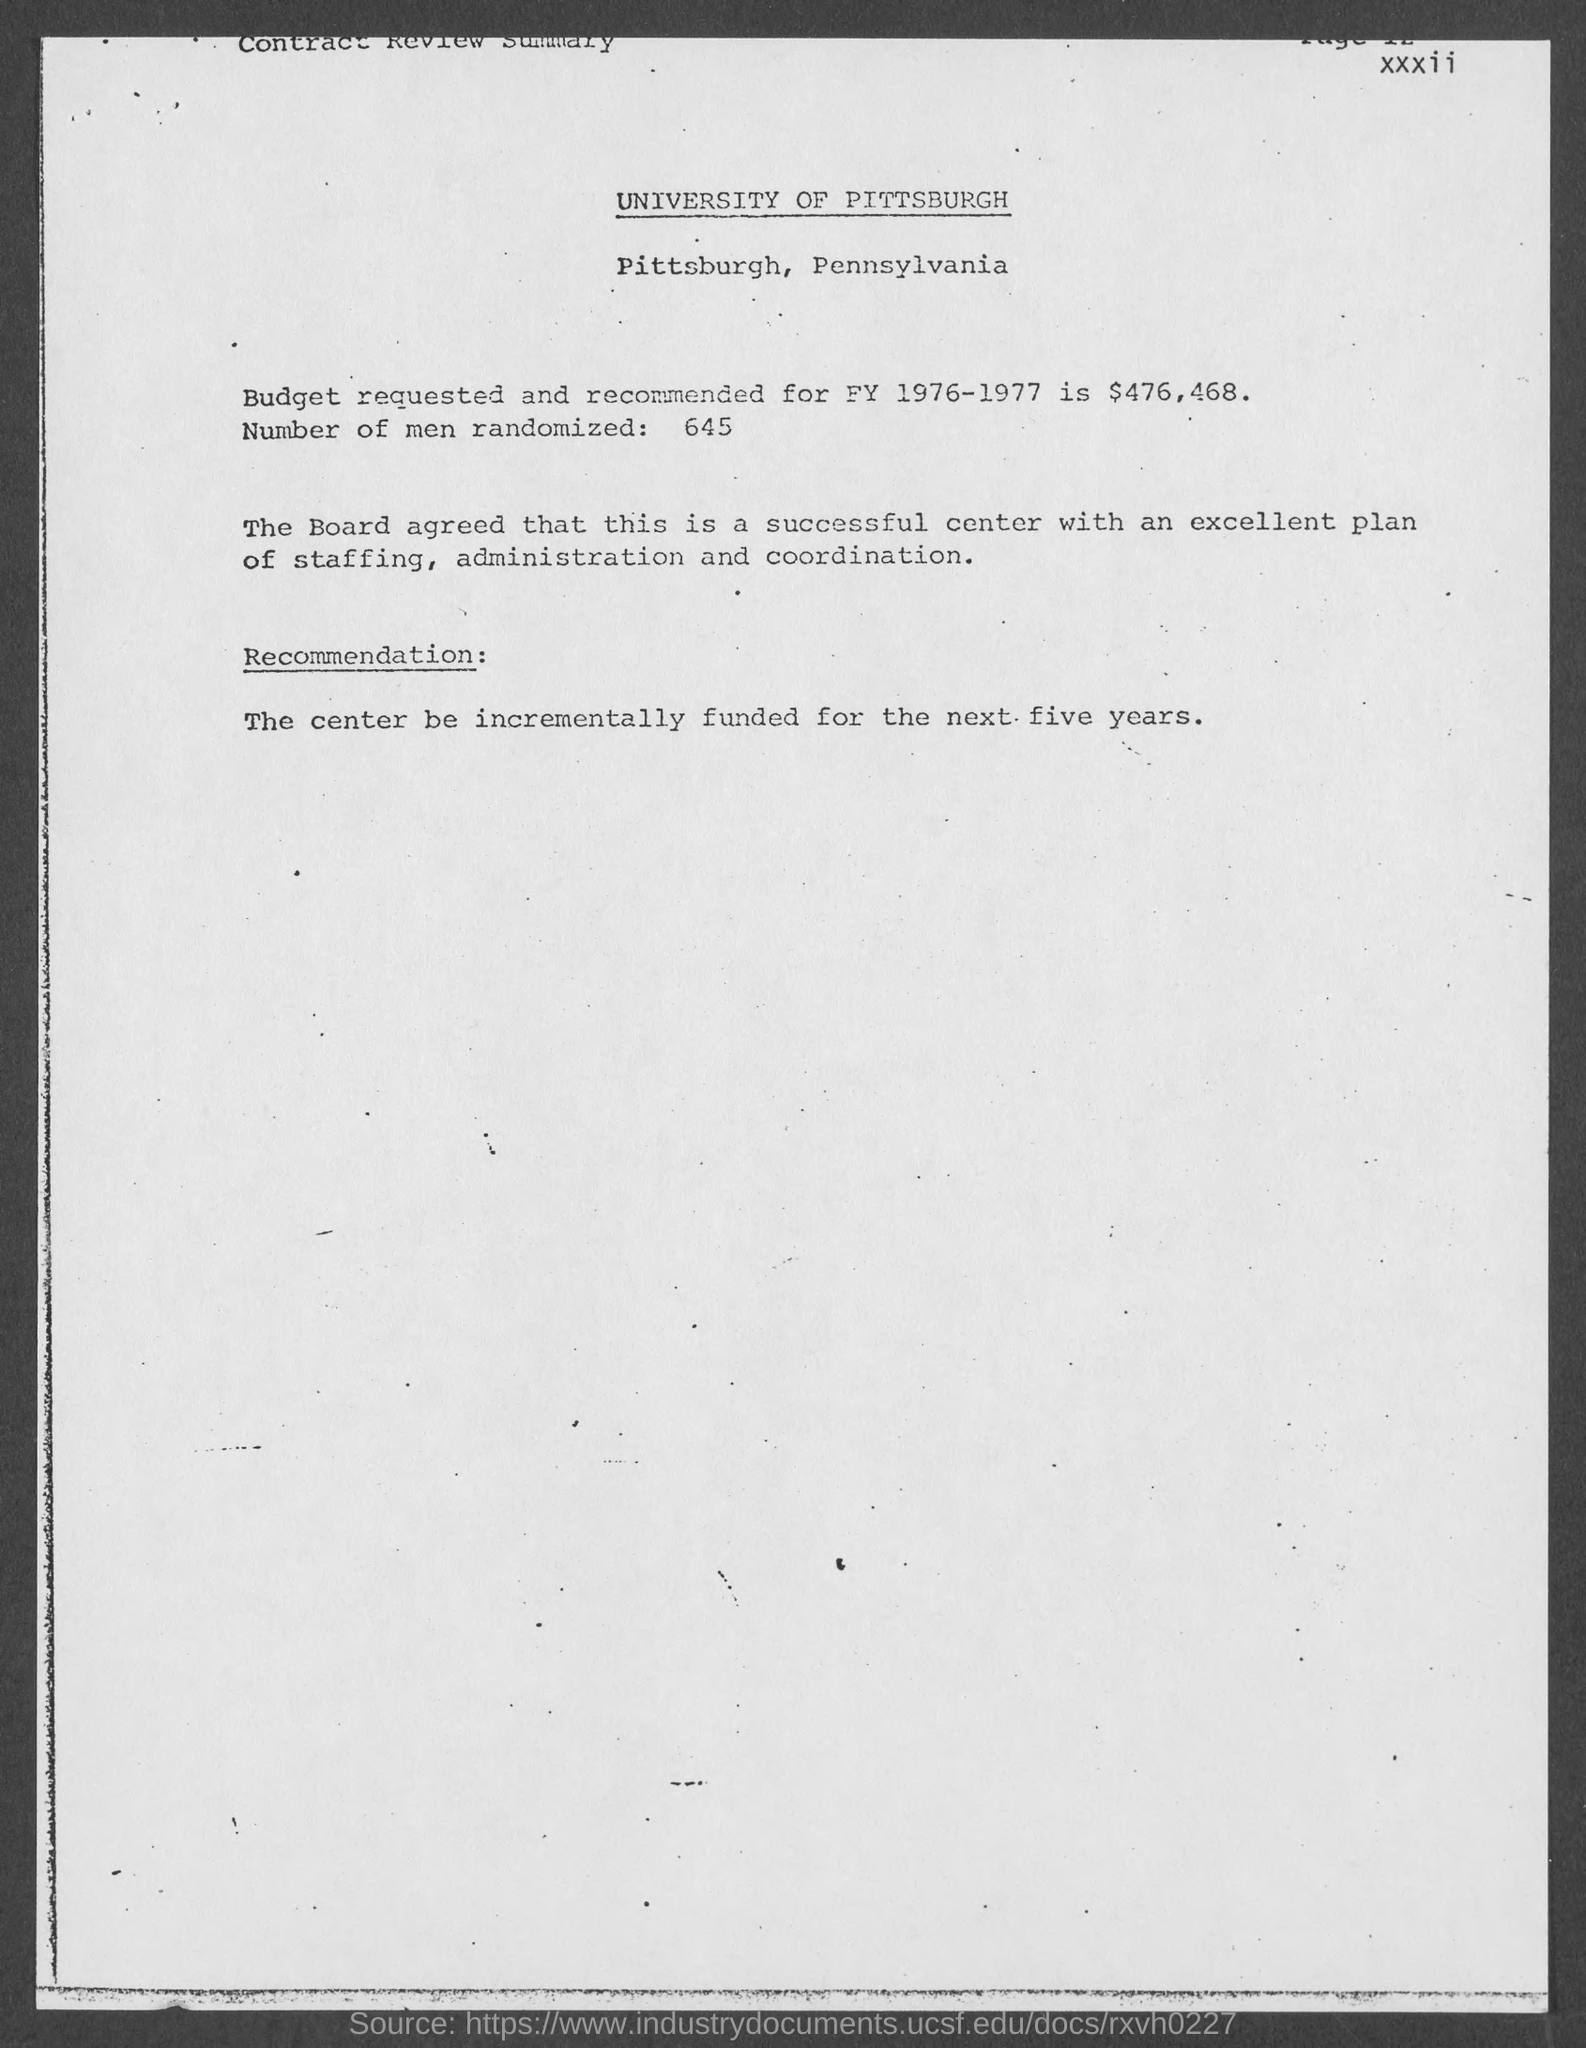Outline some significant characteristics in this image. I'm sorry, but the sentence "how many number of men are randomized ? 645.." is not grammatically correct and does not make sense. It is unclear what the author is trying to ask or express with this sentence. Can you please provide more context or clarify your question? The budget requested and recommended for fiscal year 1976-1977 is $476,468. 